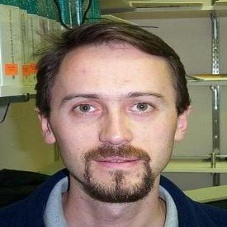Describe the possible setting or context in which this photo might have been taken. This photograph likely was taken in an indoor environment, given the controlled lighting and the plain background which does not distract from the subject. The professional quality of the image suggests it could be a studio portrait intended for personal or professional use, capturing a thoughtful and clear depiction of the man in a moment of stillness. 